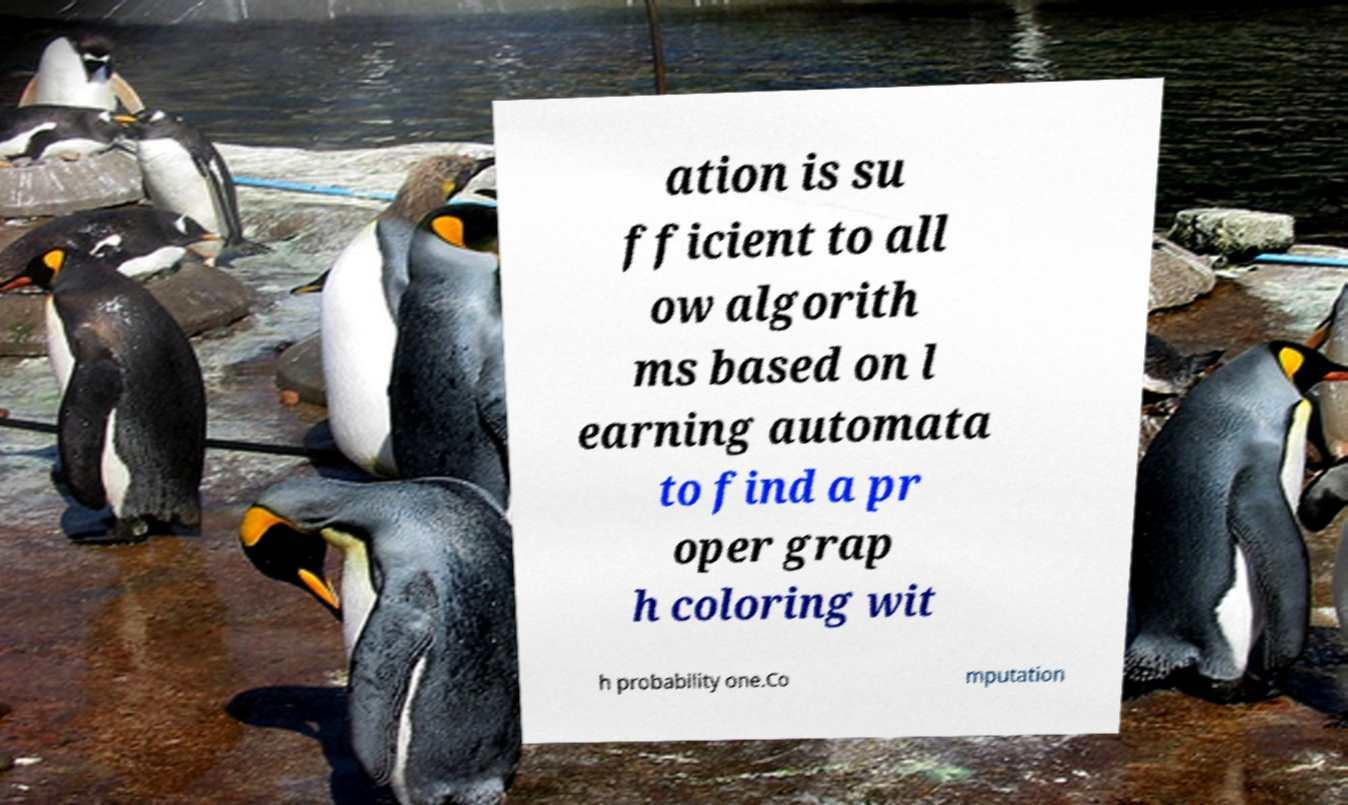Please identify and transcribe the text found in this image. ation is su fficient to all ow algorith ms based on l earning automata to find a pr oper grap h coloring wit h probability one.Co mputation 